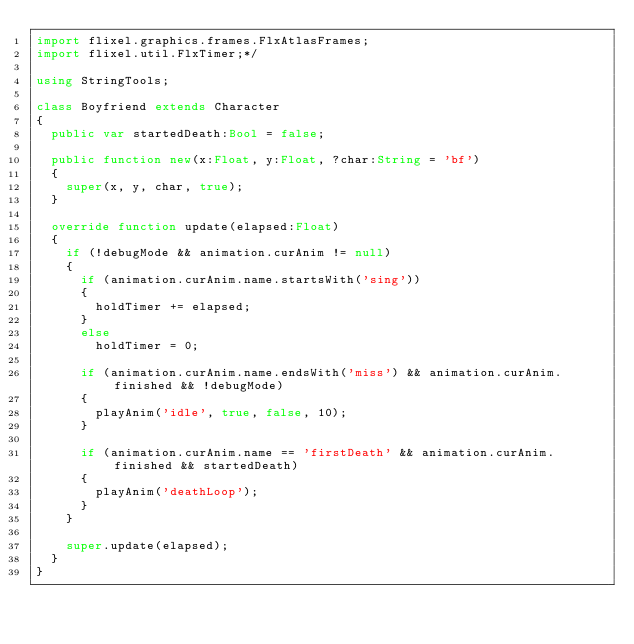Convert code to text. <code><loc_0><loc_0><loc_500><loc_500><_Haxe_>import flixel.graphics.frames.FlxAtlasFrames;
import flixel.util.FlxTimer;*/

using StringTools;

class Boyfriend extends Character
{
	public var startedDeath:Bool = false;

	public function new(x:Float, y:Float, ?char:String = 'bf')
	{
		super(x, y, char, true);
	}

	override function update(elapsed:Float)
	{
		if (!debugMode && animation.curAnim != null)
		{
			if (animation.curAnim.name.startsWith('sing'))
			{
				holdTimer += elapsed;
			}
			else
				holdTimer = 0;

			if (animation.curAnim.name.endsWith('miss') && animation.curAnim.finished && !debugMode)
			{
				playAnim('idle', true, false, 10);
			}

			if (animation.curAnim.name == 'firstDeath' && animation.curAnim.finished && startedDeath)
			{
				playAnim('deathLoop');
			}
		}

		super.update(elapsed);
	}
}
</code> 